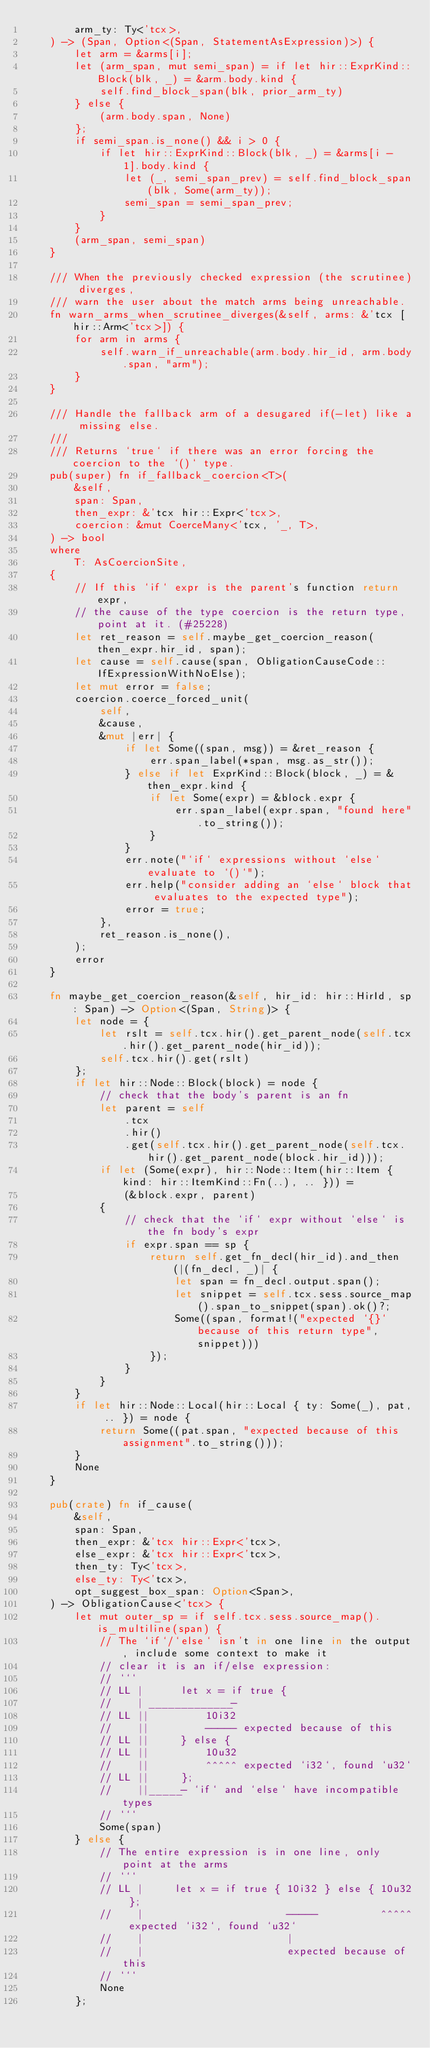Convert code to text. <code><loc_0><loc_0><loc_500><loc_500><_Rust_>        arm_ty: Ty<'tcx>,
    ) -> (Span, Option<(Span, StatementAsExpression)>) {
        let arm = &arms[i];
        let (arm_span, mut semi_span) = if let hir::ExprKind::Block(blk, _) = &arm.body.kind {
            self.find_block_span(blk, prior_arm_ty)
        } else {
            (arm.body.span, None)
        };
        if semi_span.is_none() && i > 0 {
            if let hir::ExprKind::Block(blk, _) = &arms[i - 1].body.kind {
                let (_, semi_span_prev) = self.find_block_span(blk, Some(arm_ty));
                semi_span = semi_span_prev;
            }
        }
        (arm_span, semi_span)
    }

    /// When the previously checked expression (the scrutinee) diverges,
    /// warn the user about the match arms being unreachable.
    fn warn_arms_when_scrutinee_diverges(&self, arms: &'tcx [hir::Arm<'tcx>]) {
        for arm in arms {
            self.warn_if_unreachable(arm.body.hir_id, arm.body.span, "arm");
        }
    }

    /// Handle the fallback arm of a desugared if(-let) like a missing else.
    ///
    /// Returns `true` if there was an error forcing the coercion to the `()` type.
    pub(super) fn if_fallback_coercion<T>(
        &self,
        span: Span,
        then_expr: &'tcx hir::Expr<'tcx>,
        coercion: &mut CoerceMany<'tcx, '_, T>,
    ) -> bool
    where
        T: AsCoercionSite,
    {
        // If this `if` expr is the parent's function return expr,
        // the cause of the type coercion is the return type, point at it. (#25228)
        let ret_reason = self.maybe_get_coercion_reason(then_expr.hir_id, span);
        let cause = self.cause(span, ObligationCauseCode::IfExpressionWithNoElse);
        let mut error = false;
        coercion.coerce_forced_unit(
            self,
            &cause,
            &mut |err| {
                if let Some((span, msg)) = &ret_reason {
                    err.span_label(*span, msg.as_str());
                } else if let ExprKind::Block(block, _) = &then_expr.kind {
                    if let Some(expr) = &block.expr {
                        err.span_label(expr.span, "found here".to_string());
                    }
                }
                err.note("`if` expressions without `else` evaluate to `()`");
                err.help("consider adding an `else` block that evaluates to the expected type");
                error = true;
            },
            ret_reason.is_none(),
        );
        error
    }

    fn maybe_get_coercion_reason(&self, hir_id: hir::HirId, sp: Span) -> Option<(Span, String)> {
        let node = {
            let rslt = self.tcx.hir().get_parent_node(self.tcx.hir().get_parent_node(hir_id));
            self.tcx.hir().get(rslt)
        };
        if let hir::Node::Block(block) = node {
            // check that the body's parent is an fn
            let parent = self
                .tcx
                .hir()
                .get(self.tcx.hir().get_parent_node(self.tcx.hir().get_parent_node(block.hir_id)));
            if let (Some(expr), hir::Node::Item(hir::Item { kind: hir::ItemKind::Fn(..), .. })) =
                (&block.expr, parent)
            {
                // check that the `if` expr without `else` is the fn body's expr
                if expr.span == sp {
                    return self.get_fn_decl(hir_id).and_then(|(fn_decl, _)| {
                        let span = fn_decl.output.span();
                        let snippet = self.tcx.sess.source_map().span_to_snippet(span).ok()?;
                        Some((span, format!("expected `{}` because of this return type", snippet)))
                    });
                }
            }
        }
        if let hir::Node::Local(hir::Local { ty: Some(_), pat, .. }) = node {
            return Some((pat.span, "expected because of this assignment".to_string()));
        }
        None
    }

    pub(crate) fn if_cause(
        &self,
        span: Span,
        then_expr: &'tcx hir::Expr<'tcx>,
        else_expr: &'tcx hir::Expr<'tcx>,
        then_ty: Ty<'tcx>,
        else_ty: Ty<'tcx>,
        opt_suggest_box_span: Option<Span>,
    ) -> ObligationCause<'tcx> {
        let mut outer_sp = if self.tcx.sess.source_map().is_multiline(span) {
            // The `if`/`else` isn't in one line in the output, include some context to make it
            // clear it is an if/else expression:
            // ```
            // LL |      let x = if true {
            //    | _____________-
            // LL ||         10i32
            //    ||         ----- expected because of this
            // LL ||     } else {
            // LL ||         10u32
            //    ||         ^^^^^ expected `i32`, found `u32`
            // LL ||     };
            //    ||_____- `if` and `else` have incompatible types
            // ```
            Some(span)
        } else {
            // The entire expression is in one line, only point at the arms
            // ```
            // LL |     let x = if true { 10i32 } else { 10u32 };
            //    |                       -----          ^^^^^ expected `i32`, found `u32`
            //    |                       |
            //    |                       expected because of this
            // ```
            None
        };
</code> 